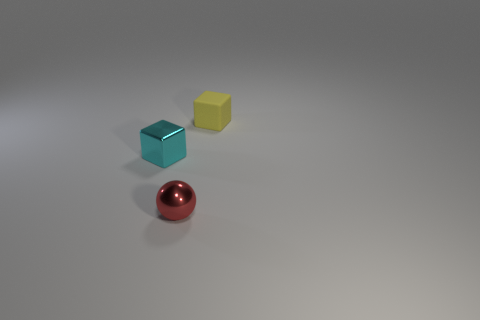Add 2 red metal balls. How many objects exist? 5 Subtract all yellow cubes. How many cubes are left? 1 Subtract all blocks. How many objects are left? 1 Subtract 1 spheres. How many spheres are left? 0 Add 2 small red spheres. How many small red spheres are left? 3 Add 1 balls. How many balls exist? 2 Subtract 0 gray balls. How many objects are left? 3 Subtract all cyan cubes. Subtract all purple spheres. How many cubes are left? 1 Subtract all gray cylinders. How many red cubes are left? 0 Subtract all yellow rubber things. Subtract all cyan things. How many objects are left? 1 